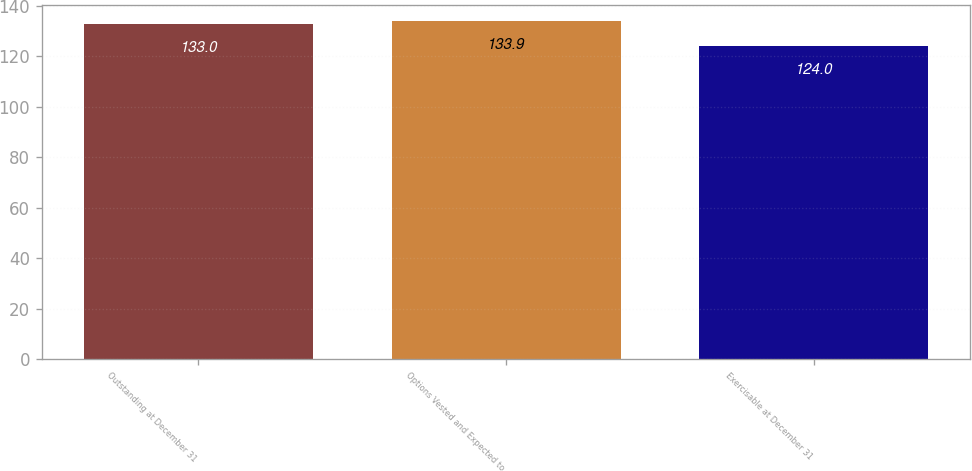<chart> <loc_0><loc_0><loc_500><loc_500><bar_chart><fcel>Outstanding at December 31<fcel>Options Vested and Expected to<fcel>Exercisable at December 31<nl><fcel>133<fcel>133.9<fcel>124<nl></chart> 